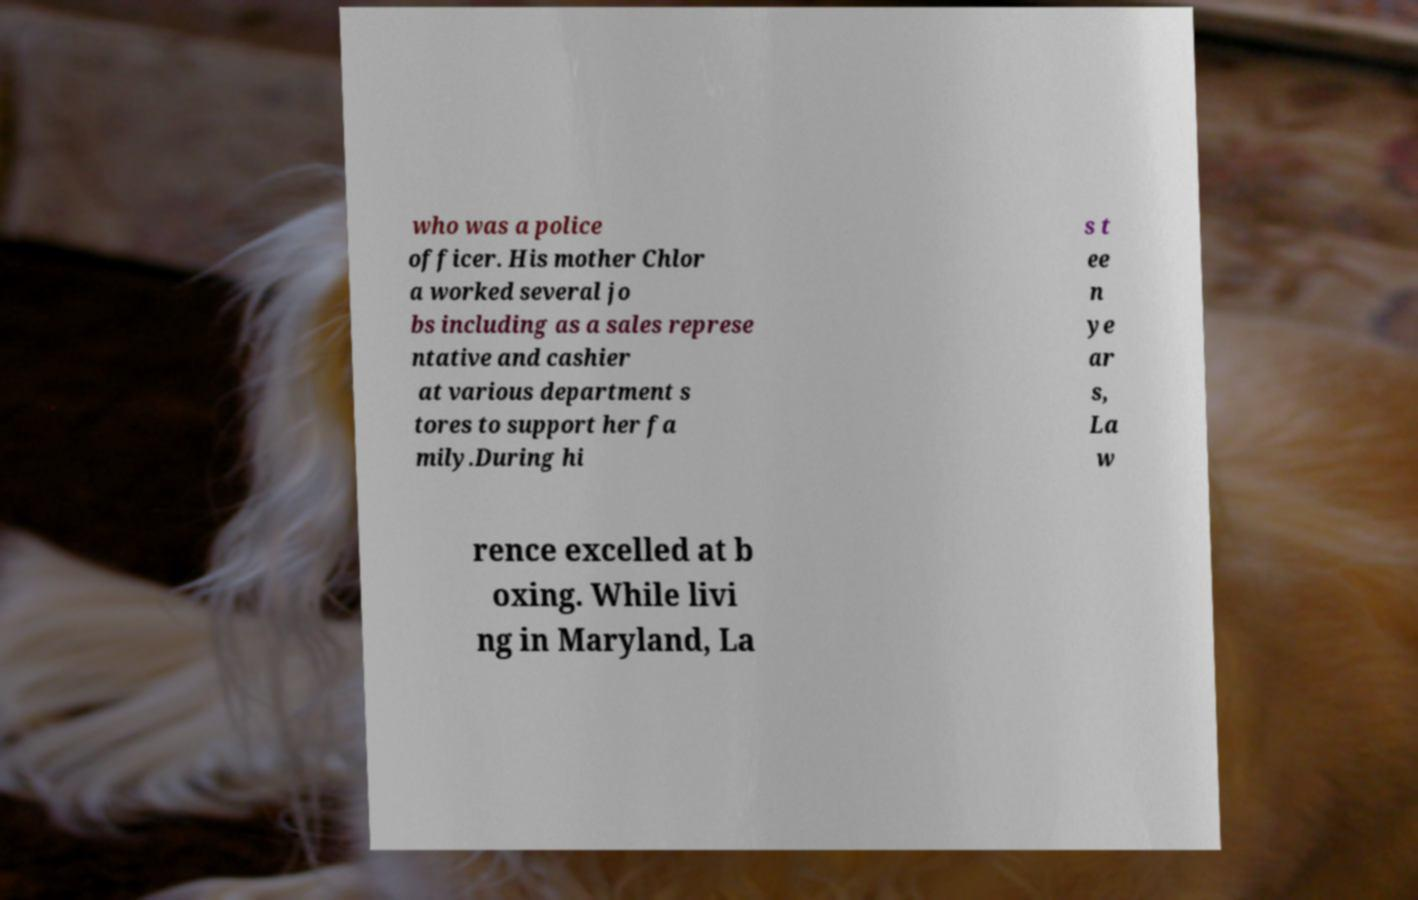Can you accurately transcribe the text from the provided image for me? who was a police officer. His mother Chlor a worked several jo bs including as a sales represe ntative and cashier at various department s tores to support her fa mily.During hi s t ee n ye ar s, La w rence excelled at b oxing. While livi ng in Maryland, La 